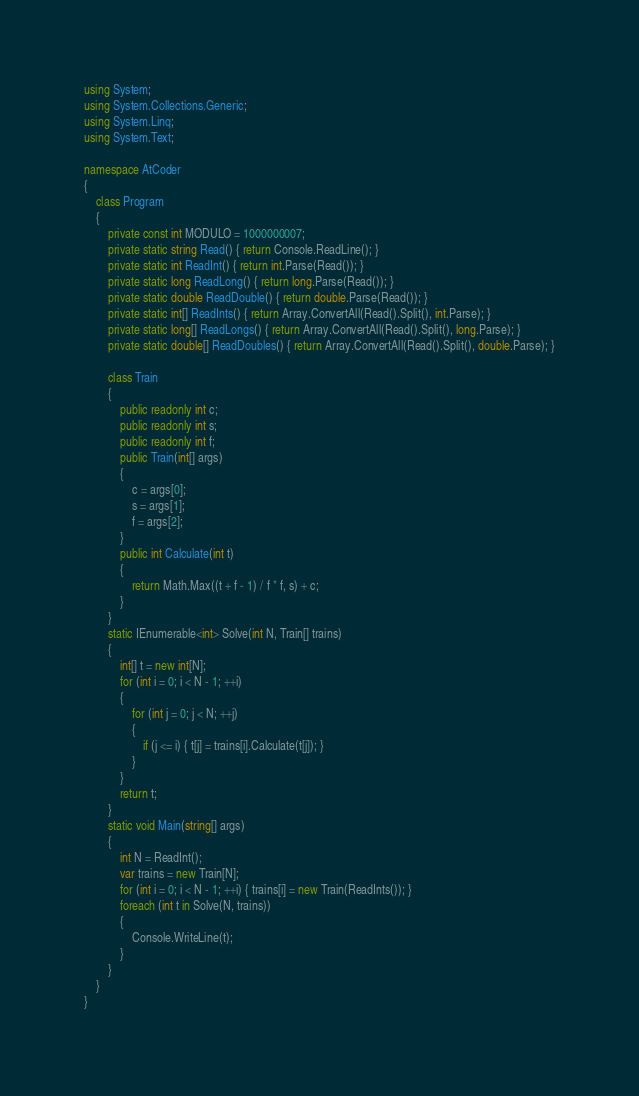<code> <loc_0><loc_0><loc_500><loc_500><_C#_>using System;
using System.Collections.Generic;
using System.Linq;
using System.Text;

namespace AtCoder
{
    class Program
    {
        private const int MODULO = 1000000007;
        private static string Read() { return Console.ReadLine(); }
        private static int ReadInt() { return int.Parse(Read()); }
        private static long ReadLong() { return long.Parse(Read()); }
        private static double ReadDouble() { return double.Parse(Read()); }
        private static int[] ReadInts() { return Array.ConvertAll(Read().Split(), int.Parse); }
        private static long[] ReadLongs() { return Array.ConvertAll(Read().Split(), long.Parse); }
        private static double[] ReadDoubles() { return Array.ConvertAll(Read().Split(), double.Parse); }

        class Train
        {
            public readonly int c;
            public readonly int s;
            public readonly int f;
            public Train(int[] args)
            {
                c = args[0];
                s = args[1];
                f = args[2];
            }
            public int Calculate(int t)
            {
                return Math.Max((t + f - 1) / f * f, s) + c;
            }
        }
        static IEnumerable<int> Solve(int N, Train[] trains)
        {
            int[] t = new int[N];
            for (int i = 0; i < N - 1; ++i)
            {
                for (int j = 0; j < N; ++j)
                {
                    if (j <= i) { t[j] = trains[i].Calculate(t[j]); }
                }
            }
            return t;
        }
        static void Main(string[] args)
        {
            int N = ReadInt();
            var trains = new Train[N];
            for (int i = 0; i < N - 1; ++i) { trains[i] = new Train(ReadInts()); }
            foreach (int t in Solve(N, trains))
            {
                Console.WriteLine(t);
            }
        }
    }
}
</code> 